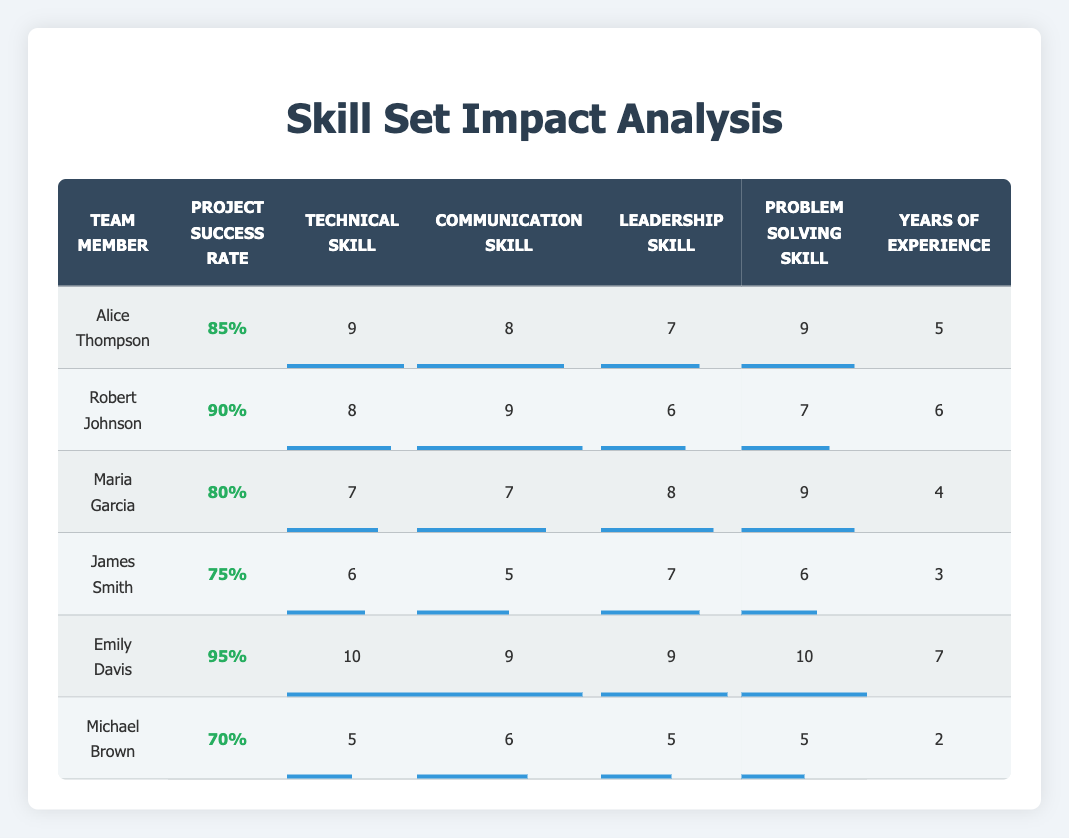What is the project success rate of Emily Davis? Looking at the table, Emily Davis has a project success rate listed under the corresponding column, which is 95%.
Answer: 95% Who has the highest technical skill level in the team? In the technical skill level column, Emily Davis has the highest score of 10, which is greater than all other team members' scores.
Answer: Emily Davis What is the average project success rate for the team members listed? To find the average, add all the project success rates: (0.85 + 0.90 + 0.80 + 0.75 + 0.95 + 0.70) = 5.15. Now, divide by the number of members (6): 5.15/6 = 0.8583, which can be rounded to 0.86.
Answer: 0.86 Is Maria Garcia's leadership skill level higher than Robert Johnson's? Looking at the leadership skill level column, Maria Garcia has a score of 8, while Robert Johnson has a score of 6. Therefore, 8 > 6 confirms that Maria’s leadership skill level is higher.
Answer: Yes How many team members have a problem-solving skill level of 8 or higher? By examining the problem-solving skill levels listed, Alice Thompson (9), Maria Garcia (9), Emily Davis (10) all have scores of 8 or higher. This totals three members.
Answer: 3 Which team member has the least years of experience, and what is that amount? By referencing the years of experience column, Michael Brown has the least at 2 years. This can be confirmed by scanning the entire column for the minimum value.
Answer: 2 years What is the difference between the highest and lowest project success rates among the team members? The highest project success rate is 95% (Emily Davis), and the lowest is 70% (Michael Brown). To find the difference: 95% - 70% = 25%.
Answer: 25% Were there more team members with a communication skill level of 7 or lower? Checking the communication skill column, James Smith (5), Michael Brown (6), and Maria Garcia (7) all fall at or below 7. There are three members, while others have scores above 7. The count of those below or equal to 7 is three; those above this threshold are three as well.
Answer: No If Alice Thompson improved her technical skills to a level of 10, what would her new project success rate need to be to maintain an overall average success rate of 0.86 for the whole team? First, calculate the total project success rate needed for an average of 0.86 across the 6 members: 0.86 * 6 = 5.16. With Alice's new success rate added, the equation becomes 5.16 - (other members' ratings excluding Alice): 5.16 - 4.30 = 0.86. Therefore, her new success rate would also need to match this average. So, Alice at 10 must hold her project success rate at least equal to or above to maintain alignment.
Answer: 0.86 